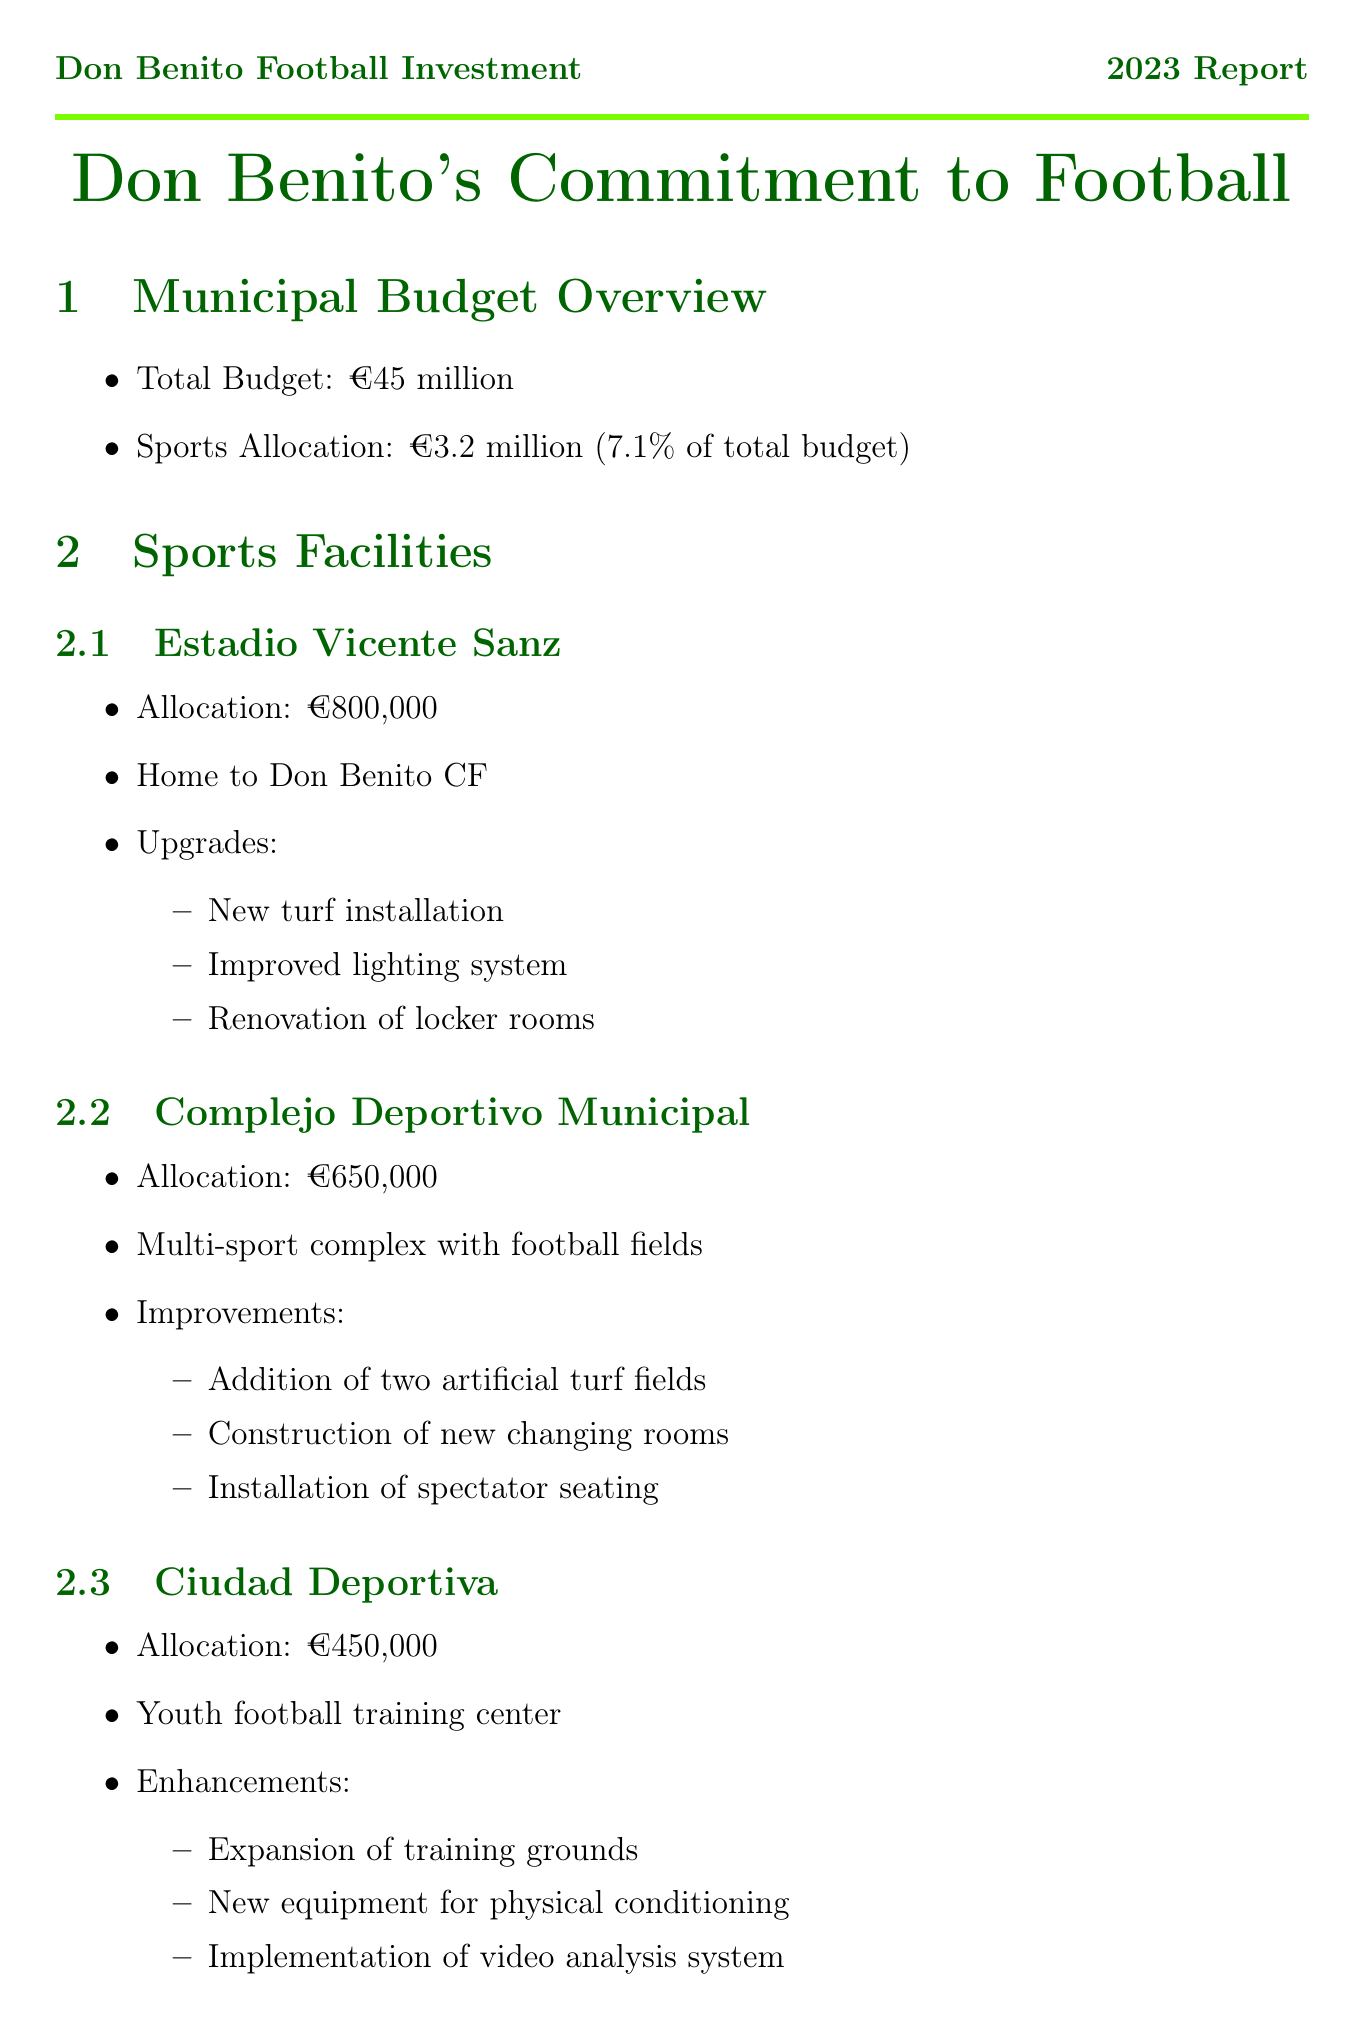What is the total municipal budget? The total municipal budget is stated in the report under the municipal budget overview section.
Answer: €45 million What is the allocation for Estadio Vicente Sanz? The report provides specific allocations for each sports facility. For Estadio Vicente Sanz, it is €800,000.
Answer: €800,000 How much is allocated to youth football programs? The total allocation for youth football programs is detailed in the document.
Answer: €700,000 What facilities will be improved at the Complejo Deportivo Municipal? The document lists improvements for each facility, highlighting the changes at Complejo Deportivo Municipal.
Answer: Addition of two artificial turf fields, construction of new changing rooms, installation of spectator seating What is the focus of the Programa de Tecnificación? The focus of this program is explained in its description within the youth football programs section.
Answer: Advanced skills development for talented young players How many jobs were created through sports initiatives? The document states the community impact, specifically the number of jobs created due to these initiatives.
Answer: 45 When is the expected completion date for the Centro de Alto Rendimiento? The future projects section includes expected completion dates for upcoming sports facilities.
Answer: 2025 Which clubs are involved in the Programa de Intercambio Internacional? The report lists the partner clubs associated with the youth exchange program in the future projects section.
Answer: Sporting CP, Ajax Amsterdam, Olympique Lyonnais Who is the ambassador for youth football programs? The document identifies local football celebrities and their roles, including the ambassador for youth football programs.
Answer: Rubén Mesa 